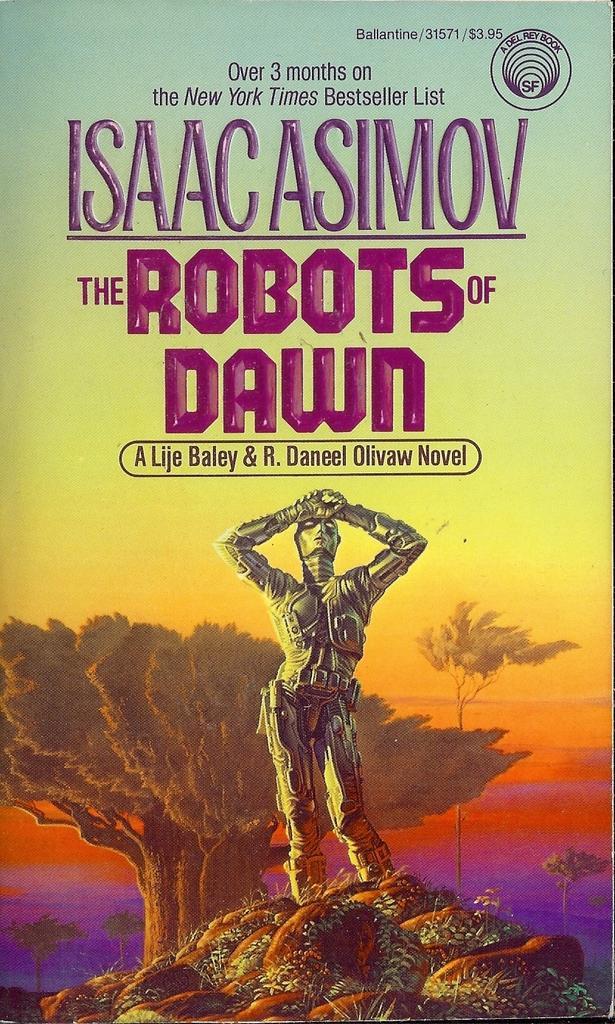Please provide a concise description of this image. This looks like a poster. I think this is a robot standing on the rocks. I can see the trees. These are the letters. 